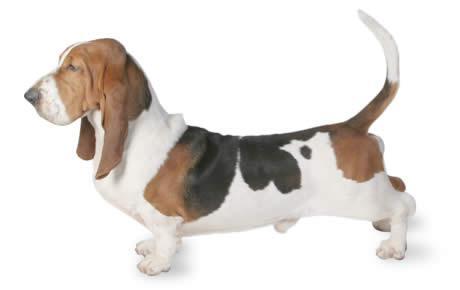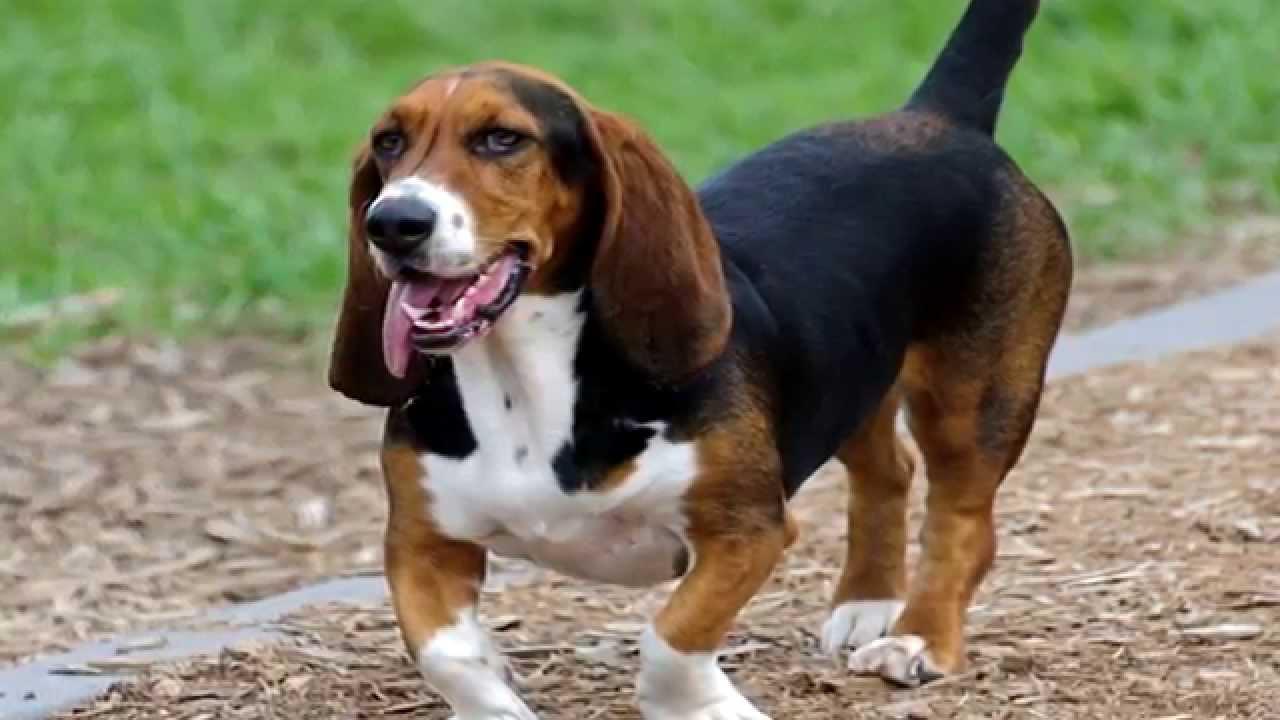The first image is the image on the left, the second image is the image on the right. Considering the images on both sides, is "Each image contains only one dog, and one image shows a basset hound standing in profile on a white background." valid? Answer yes or no. Yes. The first image is the image on the left, the second image is the image on the right. For the images displayed, is the sentence "The rear end of the dog in the image on the left is resting on the ground." factually correct? Answer yes or no. No. 